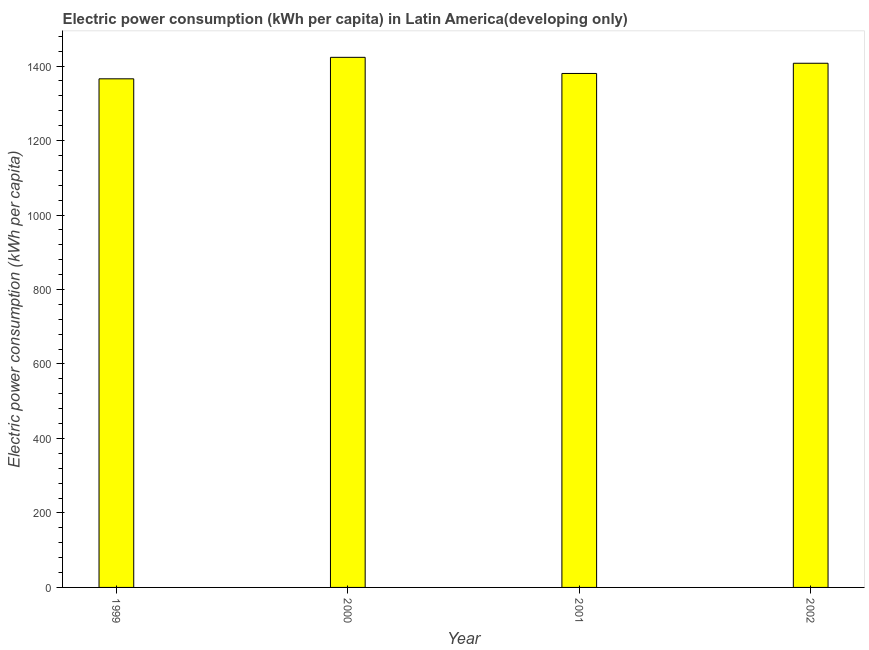What is the title of the graph?
Your answer should be very brief. Electric power consumption (kWh per capita) in Latin America(developing only). What is the label or title of the Y-axis?
Give a very brief answer. Electric power consumption (kWh per capita). What is the electric power consumption in 1999?
Ensure brevity in your answer.  1365.78. Across all years, what is the maximum electric power consumption?
Offer a very short reply. 1423.5. Across all years, what is the minimum electric power consumption?
Offer a very short reply. 1365.78. In which year was the electric power consumption maximum?
Keep it short and to the point. 2000. What is the sum of the electric power consumption?
Ensure brevity in your answer.  5577.04. What is the difference between the electric power consumption in 1999 and 2001?
Provide a short and direct response. -14.39. What is the average electric power consumption per year?
Ensure brevity in your answer.  1394.26. What is the median electric power consumption?
Keep it short and to the point. 1393.88. Do a majority of the years between 1999 and 2001 (inclusive) have electric power consumption greater than 880 kWh per capita?
Provide a succinct answer. Yes. What is the ratio of the electric power consumption in 1999 to that in 2002?
Your answer should be compact. 0.97. Is the electric power consumption in 1999 less than that in 2000?
Keep it short and to the point. Yes. What is the difference between the highest and the second highest electric power consumption?
Give a very brief answer. 15.91. Is the sum of the electric power consumption in 1999 and 2002 greater than the maximum electric power consumption across all years?
Ensure brevity in your answer.  Yes. What is the difference between the highest and the lowest electric power consumption?
Provide a succinct answer. 57.73. In how many years, is the electric power consumption greater than the average electric power consumption taken over all years?
Provide a succinct answer. 2. Are all the bars in the graph horizontal?
Ensure brevity in your answer.  No. How many years are there in the graph?
Offer a terse response. 4. What is the difference between two consecutive major ticks on the Y-axis?
Give a very brief answer. 200. Are the values on the major ticks of Y-axis written in scientific E-notation?
Your answer should be compact. No. What is the Electric power consumption (kWh per capita) of 1999?
Your answer should be very brief. 1365.78. What is the Electric power consumption (kWh per capita) in 2000?
Your response must be concise. 1423.5. What is the Electric power consumption (kWh per capita) in 2001?
Keep it short and to the point. 1380.17. What is the Electric power consumption (kWh per capita) in 2002?
Your answer should be very brief. 1407.6. What is the difference between the Electric power consumption (kWh per capita) in 1999 and 2000?
Offer a terse response. -57.73. What is the difference between the Electric power consumption (kWh per capita) in 1999 and 2001?
Give a very brief answer. -14.39. What is the difference between the Electric power consumption (kWh per capita) in 1999 and 2002?
Provide a succinct answer. -41.82. What is the difference between the Electric power consumption (kWh per capita) in 2000 and 2001?
Your answer should be compact. 43.34. What is the difference between the Electric power consumption (kWh per capita) in 2000 and 2002?
Offer a terse response. 15.91. What is the difference between the Electric power consumption (kWh per capita) in 2001 and 2002?
Your response must be concise. -27.43. What is the ratio of the Electric power consumption (kWh per capita) in 1999 to that in 2000?
Ensure brevity in your answer.  0.96. What is the ratio of the Electric power consumption (kWh per capita) in 1999 to that in 2002?
Your answer should be compact. 0.97. What is the ratio of the Electric power consumption (kWh per capita) in 2000 to that in 2001?
Give a very brief answer. 1.03. What is the ratio of the Electric power consumption (kWh per capita) in 2000 to that in 2002?
Your response must be concise. 1.01. What is the ratio of the Electric power consumption (kWh per capita) in 2001 to that in 2002?
Your answer should be compact. 0.98. 